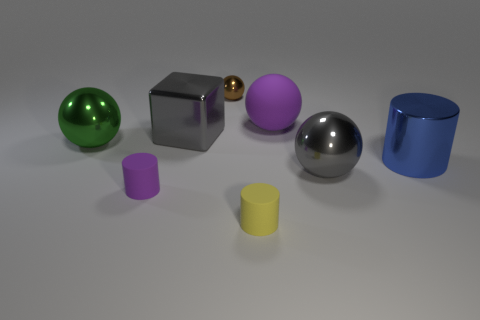Does the large blue object have the same material as the big gray block?
Keep it short and to the point. Yes. How many cyan objects are either tiny metallic spheres or cubes?
Keep it short and to the point. 0. Is the number of tiny purple things that are in front of the green metallic thing greater than the number of gray matte cylinders?
Provide a succinct answer. Yes. Is there a large metal block that has the same color as the big matte sphere?
Offer a very short reply. No. How big is the yellow cylinder?
Ensure brevity in your answer.  Small. Do the rubber sphere and the metal cube have the same color?
Offer a terse response. No. How many things are large gray objects or tiny matte things left of the big gray metallic block?
Your answer should be very brief. 3. How many tiny matte objects are on the left side of the small metallic ball that is on the left side of the big shiny ball that is in front of the big green shiny object?
Offer a very short reply. 1. There is a large ball that is the same color as the big metal block; what material is it?
Provide a short and direct response. Metal. What number of metallic balls are there?
Provide a succinct answer. 3. 